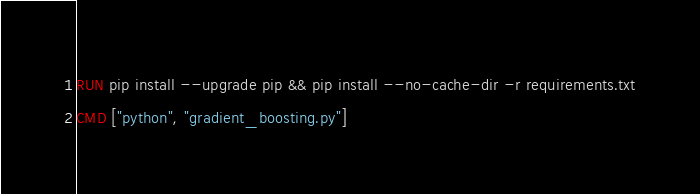Convert code to text. <code><loc_0><loc_0><loc_500><loc_500><_Dockerfile_>RUN pip install --upgrade pip && pip install --no-cache-dir -r requirements.txt
CMD ["python", "gradient_boosting.py"]</code> 